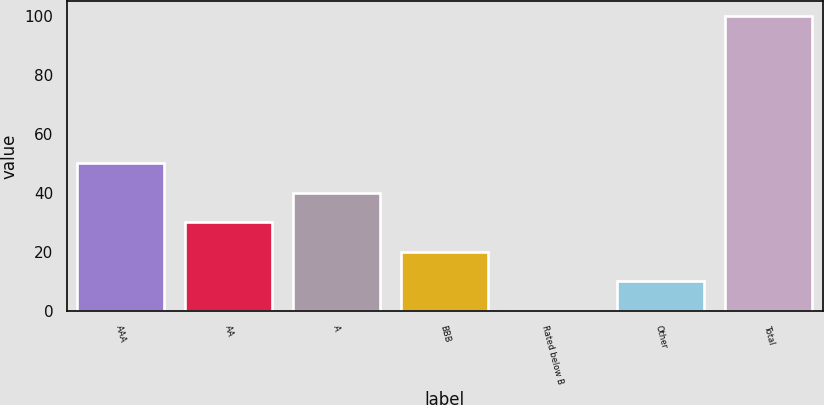Convert chart to OTSL. <chart><loc_0><loc_0><loc_500><loc_500><bar_chart><fcel>AAA<fcel>AA<fcel>A<fcel>BBB<fcel>Rated below B<fcel>Other<fcel>Total<nl><fcel>50.1<fcel>30.14<fcel>40.12<fcel>20.16<fcel>0.2<fcel>10.18<fcel>100<nl></chart> 